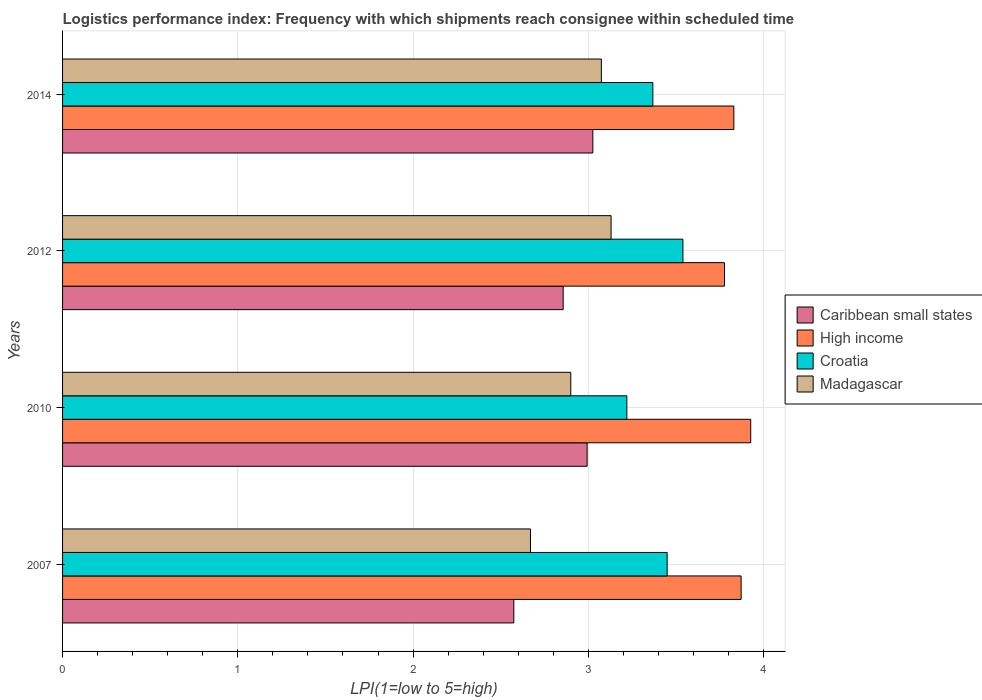How many different coloured bars are there?
Give a very brief answer. 4. Are the number of bars per tick equal to the number of legend labels?
Offer a terse response. Yes. How many bars are there on the 2nd tick from the top?
Offer a very short reply. 4. How many bars are there on the 1st tick from the bottom?
Your response must be concise. 4. What is the logistics performance index in Caribbean small states in 2012?
Ensure brevity in your answer.  2.86. Across all years, what is the maximum logistics performance index in High income?
Offer a very short reply. 3.93. Across all years, what is the minimum logistics performance index in High income?
Your response must be concise. 3.78. In which year was the logistics performance index in Madagascar maximum?
Keep it short and to the point. 2012. What is the total logistics performance index in Madagascar in the graph?
Give a very brief answer. 11.77. What is the difference between the logistics performance index in Madagascar in 2010 and that in 2012?
Give a very brief answer. -0.23. What is the difference between the logistics performance index in Caribbean small states in 2014 and the logistics performance index in Madagascar in 2012?
Provide a short and direct response. -0.1. What is the average logistics performance index in High income per year?
Your answer should be compact. 3.85. In the year 2014, what is the difference between the logistics performance index in Madagascar and logistics performance index in Croatia?
Keep it short and to the point. -0.29. What is the ratio of the logistics performance index in High income in 2007 to that in 2012?
Your response must be concise. 1.03. Is the difference between the logistics performance index in Madagascar in 2010 and 2014 greater than the difference between the logistics performance index in Croatia in 2010 and 2014?
Give a very brief answer. No. What is the difference between the highest and the second highest logistics performance index in Croatia?
Provide a succinct answer. 0.09. What is the difference between the highest and the lowest logistics performance index in Caribbean small states?
Give a very brief answer. 0.45. In how many years, is the logistics performance index in Caribbean small states greater than the average logistics performance index in Caribbean small states taken over all years?
Ensure brevity in your answer.  2. Is the sum of the logistics performance index in Madagascar in 2007 and 2012 greater than the maximum logistics performance index in Croatia across all years?
Offer a terse response. Yes. Is it the case that in every year, the sum of the logistics performance index in Madagascar and logistics performance index in Croatia is greater than the sum of logistics performance index in Caribbean small states and logistics performance index in High income?
Keep it short and to the point. No. How many bars are there?
Your answer should be very brief. 16. How many years are there in the graph?
Give a very brief answer. 4. Are the values on the major ticks of X-axis written in scientific E-notation?
Offer a very short reply. No. How many legend labels are there?
Offer a terse response. 4. What is the title of the graph?
Your answer should be very brief. Logistics performance index: Frequency with which shipments reach consignee within scheduled time. What is the label or title of the X-axis?
Make the answer very short. LPI(1=low to 5=high). What is the label or title of the Y-axis?
Keep it short and to the point. Years. What is the LPI(1=low to 5=high) of Caribbean small states in 2007?
Ensure brevity in your answer.  2.58. What is the LPI(1=low to 5=high) of High income in 2007?
Ensure brevity in your answer.  3.87. What is the LPI(1=low to 5=high) in Croatia in 2007?
Give a very brief answer. 3.45. What is the LPI(1=low to 5=high) of Madagascar in 2007?
Make the answer very short. 2.67. What is the LPI(1=low to 5=high) in Caribbean small states in 2010?
Keep it short and to the point. 2.99. What is the LPI(1=low to 5=high) in High income in 2010?
Give a very brief answer. 3.93. What is the LPI(1=low to 5=high) of Croatia in 2010?
Your answer should be compact. 3.22. What is the LPI(1=low to 5=high) of Madagascar in 2010?
Ensure brevity in your answer.  2.9. What is the LPI(1=low to 5=high) of Caribbean small states in 2012?
Give a very brief answer. 2.86. What is the LPI(1=low to 5=high) in High income in 2012?
Give a very brief answer. 3.78. What is the LPI(1=low to 5=high) in Croatia in 2012?
Your response must be concise. 3.54. What is the LPI(1=low to 5=high) of Madagascar in 2012?
Ensure brevity in your answer.  3.13. What is the LPI(1=low to 5=high) in Caribbean small states in 2014?
Keep it short and to the point. 3.03. What is the LPI(1=low to 5=high) in High income in 2014?
Ensure brevity in your answer.  3.83. What is the LPI(1=low to 5=high) of Croatia in 2014?
Your answer should be compact. 3.37. What is the LPI(1=low to 5=high) of Madagascar in 2014?
Your response must be concise. 3.07. Across all years, what is the maximum LPI(1=low to 5=high) in Caribbean small states?
Offer a very short reply. 3.03. Across all years, what is the maximum LPI(1=low to 5=high) of High income?
Ensure brevity in your answer.  3.93. Across all years, what is the maximum LPI(1=low to 5=high) in Croatia?
Keep it short and to the point. 3.54. Across all years, what is the maximum LPI(1=low to 5=high) of Madagascar?
Ensure brevity in your answer.  3.13. Across all years, what is the minimum LPI(1=low to 5=high) of Caribbean small states?
Make the answer very short. 2.58. Across all years, what is the minimum LPI(1=low to 5=high) of High income?
Keep it short and to the point. 3.78. Across all years, what is the minimum LPI(1=low to 5=high) in Croatia?
Your answer should be very brief. 3.22. Across all years, what is the minimum LPI(1=low to 5=high) of Madagascar?
Provide a succinct answer. 2.67. What is the total LPI(1=low to 5=high) in Caribbean small states in the graph?
Ensure brevity in your answer.  11.45. What is the total LPI(1=low to 5=high) of High income in the graph?
Your answer should be compact. 15.41. What is the total LPI(1=low to 5=high) of Croatia in the graph?
Make the answer very short. 13.58. What is the total LPI(1=low to 5=high) in Madagascar in the graph?
Ensure brevity in your answer.  11.77. What is the difference between the LPI(1=low to 5=high) in Caribbean small states in 2007 and that in 2010?
Your response must be concise. -0.42. What is the difference between the LPI(1=low to 5=high) in High income in 2007 and that in 2010?
Keep it short and to the point. -0.05. What is the difference between the LPI(1=low to 5=high) in Croatia in 2007 and that in 2010?
Your answer should be very brief. 0.23. What is the difference between the LPI(1=low to 5=high) in Madagascar in 2007 and that in 2010?
Your answer should be compact. -0.23. What is the difference between the LPI(1=low to 5=high) of Caribbean small states in 2007 and that in 2012?
Offer a very short reply. -0.28. What is the difference between the LPI(1=low to 5=high) in High income in 2007 and that in 2012?
Keep it short and to the point. 0.09. What is the difference between the LPI(1=low to 5=high) of Croatia in 2007 and that in 2012?
Provide a short and direct response. -0.09. What is the difference between the LPI(1=low to 5=high) of Madagascar in 2007 and that in 2012?
Your answer should be compact. -0.46. What is the difference between the LPI(1=low to 5=high) of Caribbean small states in 2007 and that in 2014?
Offer a very short reply. -0.45. What is the difference between the LPI(1=low to 5=high) of High income in 2007 and that in 2014?
Your answer should be very brief. 0.04. What is the difference between the LPI(1=low to 5=high) of Croatia in 2007 and that in 2014?
Offer a terse response. 0.08. What is the difference between the LPI(1=low to 5=high) of Madagascar in 2007 and that in 2014?
Provide a succinct answer. -0.4. What is the difference between the LPI(1=low to 5=high) in Caribbean small states in 2010 and that in 2012?
Give a very brief answer. 0.14. What is the difference between the LPI(1=low to 5=high) in High income in 2010 and that in 2012?
Offer a very short reply. 0.15. What is the difference between the LPI(1=low to 5=high) of Croatia in 2010 and that in 2012?
Offer a very short reply. -0.32. What is the difference between the LPI(1=low to 5=high) of Madagascar in 2010 and that in 2012?
Make the answer very short. -0.23. What is the difference between the LPI(1=low to 5=high) in Caribbean small states in 2010 and that in 2014?
Make the answer very short. -0.03. What is the difference between the LPI(1=low to 5=high) in High income in 2010 and that in 2014?
Ensure brevity in your answer.  0.1. What is the difference between the LPI(1=low to 5=high) in Croatia in 2010 and that in 2014?
Provide a short and direct response. -0.15. What is the difference between the LPI(1=low to 5=high) in Madagascar in 2010 and that in 2014?
Your answer should be compact. -0.17. What is the difference between the LPI(1=low to 5=high) of Caribbean small states in 2012 and that in 2014?
Keep it short and to the point. -0.17. What is the difference between the LPI(1=low to 5=high) of High income in 2012 and that in 2014?
Your response must be concise. -0.05. What is the difference between the LPI(1=low to 5=high) of Croatia in 2012 and that in 2014?
Keep it short and to the point. 0.17. What is the difference between the LPI(1=low to 5=high) of Madagascar in 2012 and that in 2014?
Provide a short and direct response. 0.06. What is the difference between the LPI(1=low to 5=high) of Caribbean small states in 2007 and the LPI(1=low to 5=high) of High income in 2010?
Give a very brief answer. -1.35. What is the difference between the LPI(1=low to 5=high) in Caribbean small states in 2007 and the LPI(1=low to 5=high) in Croatia in 2010?
Give a very brief answer. -0.65. What is the difference between the LPI(1=low to 5=high) in Caribbean small states in 2007 and the LPI(1=low to 5=high) in Madagascar in 2010?
Give a very brief answer. -0.33. What is the difference between the LPI(1=low to 5=high) in High income in 2007 and the LPI(1=low to 5=high) in Croatia in 2010?
Provide a short and direct response. 0.65. What is the difference between the LPI(1=low to 5=high) in High income in 2007 and the LPI(1=low to 5=high) in Madagascar in 2010?
Offer a very short reply. 0.97. What is the difference between the LPI(1=low to 5=high) of Croatia in 2007 and the LPI(1=low to 5=high) of Madagascar in 2010?
Offer a very short reply. 0.55. What is the difference between the LPI(1=low to 5=high) of Caribbean small states in 2007 and the LPI(1=low to 5=high) of High income in 2012?
Make the answer very short. -1.2. What is the difference between the LPI(1=low to 5=high) of Caribbean small states in 2007 and the LPI(1=low to 5=high) of Croatia in 2012?
Keep it short and to the point. -0.96. What is the difference between the LPI(1=low to 5=high) in Caribbean small states in 2007 and the LPI(1=low to 5=high) in Madagascar in 2012?
Your response must be concise. -0.56. What is the difference between the LPI(1=low to 5=high) of High income in 2007 and the LPI(1=low to 5=high) of Croatia in 2012?
Offer a terse response. 0.33. What is the difference between the LPI(1=low to 5=high) of High income in 2007 and the LPI(1=low to 5=high) of Madagascar in 2012?
Provide a short and direct response. 0.74. What is the difference between the LPI(1=low to 5=high) of Croatia in 2007 and the LPI(1=low to 5=high) of Madagascar in 2012?
Give a very brief answer. 0.32. What is the difference between the LPI(1=low to 5=high) of Caribbean small states in 2007 and the LPI(1=low to 5=high) of High income in 2014?
Give a very brief answer. -1.26. What is the difference between the LPI(1=low to 5=high) in Caribbean small states in 2007 and the LPI(1=low to 5=high) in Croatia in 2014?
Your response must be concise. -0.79. What is the difference between the LPI(1=low to 5=high) in Caribbean small states in 2007 and the LPI(1=low to 5=high) in Madagascar in 2014?
Your answer should be compact. -0.5. What is the difference between the LPI(1=low to 5=high) in High income in 2007 and the LPI(1=low to 5=high) in Croatia in 2014?
Your answer should be very brief. 0.5. What is the difference between the LPI(1=low to 5=high) in High income in 2007 and the LPI(1=low to 5=high) in Madagascar in 2014?
Provide a succinct answer. 0.8. What is the difference between the LPI(1=low to 5=high) in Croatia in 2007 and the LPI(1=low to 5=high) in Madagascar in 2014?
Your response must be concise. 0.38. What is the difference between the LPI(1=low to 5=high) of Caribbean small states in 2010 and the LPI(1=low to 5=high) of High income in 2012?
Provide a succinct answer. -0.78. What is the difference between the LPI(1=low to 5=high) of Caribbean small states in 2010 and the LPI(1=low to 5=high) of Croatia in 2012?
Your answer should be compact. -0.55. What is the difference between the LPI(1=low to 5=high) of Caribbean small states in 2010 and the LPI(1=low to 5=high) of Madagascar in 2012?
Offer a very short reply. -0.14. What is the difference between the LPI(1=low to 5=high) in High income in 2010 and the LPI(1=low to 5=high) in Croatia in 2012?
Make the answer very short. 0.39. What is the difference between the LPI(1=low to 5=high) of High income in 2010 and the LPI(1=low to 5=high) of Madagascar in 2012?
Offer a very short reply. 0.8. What is the difference between the LPI(1=low to 5=high) in Croatia in 2010 and the LPI(1=low to 5=high) in Madagascar in 2012?
Your answer should be compact. 0.09. What is the difference between the LPI(1=low to 5=high) in Caribbean small states in 2010 and the LPI(1=low to 5=high) in High income in 2014?
Your answer should be compact. -0.84. What is the difference between the LPI(1=low to 5=high) in Caribbean small states in 2010 and the LPI(1=low to 5=high) in Croatia in 2014?
Your response must be concise. -0.38. What is the difference between the LPI(1=low to 5=high) in Caribbean small states in 2010 and the LPI(1=low to 5=high) in Madagascar in 2014?
Offer a terse response. -0.08. What is the difference between the LPI(1=low to 5=high) in High income in 2010 and the LPI(1=low to 5=high) in Croatia in 2014?
Provide a succinct answer. 0.56. What is the difference between the LPI(1=low to 5=high) in High income in 2010 and the LPI(1=low to 5=high) in Madagascar in 2014?
Make the answer very short. 0.85. What is the difference between the LPI(1=low to 5=high) in Croatia in 2010 and the LPI(1=low to 5=high) in Madagascar in 2014?
Keep it short and to the point. 0.15. What is the difference between the LPI(1=low to 5=high) of Caribbean small states in 2012 and the LPI(1=low to 5=high) of High income in 2014?
Give a very brief answer. -0.97. What is the difference between the LPI(1=low to 5=high) in Caribbean small states in 2012 and the LPI(1=low to 5=high) in Croatia in 2014?
Give a very brief answer. -0.51. What is the difference between the LPI(1=low to 5=high) of Caribbean small states in 2012 and the LPI(1=low to 5=high) of Madagascar in 2014?
Your response must be concise. -0.22. What is the difference between the LPI(1=low to 5=high) of High income in 2012 and the LPI(1=low to 5=high) of Croatia in 2014?
Your response must be concise. 0.41. What is the difference between the LPI(1=low to 5=high) in High income in 2012 and the LPI(1=low to 5=high) in Madagascar in 2014?
Offer a very short reply. 0.7. What is the difference between the LPI(1=low to 5=high) of Croatia in 2012 and the LPI(1=low to 5=high) of Madagascar in 2014?
Your answer should be very brief. 0.47. What is the average LPI(1=low to 5=high) in Caribbean small states per year?
Make the answer very short. 2.86. What is the average LPI(1=low to 5=high) of High income per year?
Keep it short and to the point. 3.85. What is the average LPI(1=low to 5=high) of Croatia per year?
Offer a terse response. 3.39. What is the average LPI(1=low to 5=high) of Madagascar per year?
Provide a short and direct response. 2.94. In the year 2007, what is the difference between the LPI(1=low to 5=high) in Caribbean small states and LPI(1=low to 5=high) in High income?
Your response must be concise. -1.3. In the year 2007, what is the difference between the LPI(1=low to 5=high) of Caribbean small states and LPI(1=low to 5=high) of Croatia?
Your answer should be very brief. -0.88. In the year 2007, what is the difference between the LPI(1=low to 5=high) of Caribbean small states and LPI(1=low to 5=high) of Madagascar?
Your answer should be very brief. -0.1. In the year 2007, what is the difference between the LPI(1=low to 5=high) of High income and LPI(1=low to 5=high) of Croatia?
Make the answer very short. 0.42. In the year 2007, what is the difference between the LPI(1=low to 5=high) in High income and LPI(1=low to 5=high) in Madagascar?
Make the answer very short. 1.2. In the year 2007, what is the difference between the LPI(1=low to 5=high) in Croatia and LPI(1=low to 5=high) in Madagascar?
Offer a terse response. 0.78. In the year 2010, what is the difference between the LPI(1=low to 5=high) in Caribbean small states and LPI(1=low to 5=high) in High income?
Provide a succinct answer. -0.93. In the year 2010, what is the difference between the LPI(1=low to 5=high) in Caribbean small states and LPI(1=low to 5=high) in Croatia?
Your response must be concise. -0.23. In the year 2010, what is the difference between the LPI(1=low to 5=high) in Caribbean small states and LPI(1=low to 5=high) in Madagascar?
Your response must be concise. 0.09. In the year 2010, what is the difference between the LPI(1=low to 5=high) in High income and LPI(1=low to 5=high) in Croatia?
Your answer should be compact. 0.71. In the year 2010, what is the difference between the LPI(1=low to 5=high) of High income and LPI(1=low to 5=high) of Madagascar?
Your answer should be very brief. 1.03. In the year 2010, what is the difference between the LPI(1=low to 5=high) of Croatia and LPI(1=low to 5=high) of Madagascar?
Your answer should be very brief. 0.32. In the year 2012, what is the difference between the LPI(1=low to 5=high) in Caribbean small states and LPI(1=low to 5=high) in High income?
Your response must be concise. -0.92. In the year 2012, what is the difference between the LPI(1=low to 5=high) in Caribbean small states and LPI(1=low to 5=high) in Croatia?
Your response must be concise. -0.68. In the year 2012, what is the difference between the LPI(1=low to 5=high) in Caribbean small states and LPI(1=low to 5=high) in Madagascar?
Your response must be concise. -0.27. In the year 2012, what is the difference between the LPI(1=low to 5=high) in High income and LPI(1=low to 5=high) in Croatia?
Offer a terse response. 0.24. In the year 2012, what is the difference between the LPI(1=low to 5=high) of High income and LPI(1=low to 5=high) of Madagascar?
Provide a short and direct response. 0.65. In the year 2012, what is the difference between the LPI(1=low to 5=high) of Croatia and LPI(1=low to 5=high) of Madagascar?
Your response must be concise. 0.41. In the year 2014, what is the difference between the LPI(1=low to 5=high) of Caribbean small states and LPI(1=low to 5=high) of High income?
Keep it short and to the point. -0.8. In the year 2014, what is the difference between the LPI(1=low to 5=high) in Caribbean small states and LPI(1=low to 5=high) in Croatia?
Make the answer very short. -0.34. In the year 2014, what is the difference between the LPI(1=low to 5=high) of Caribbean small states and LPI(1=low to 5=high) of Madagascar?
Make the answer very short. -0.05. In the year 2014, what is the difference between the LPI(1=low to 5=high) of High income and LPI(1=low to 5=high) of Croatia?
Your answer should be compact. 0.46. In the year 2014, what is the difference between the LPI(1=low to 5=high) of High income and LPI(1=low to 5=high) of Madagascar?
Your answer should be compact. 0.76. In the year 2014, what is the difference between the LPI(1=low to 5=high) of Croatia and LPI(1=low to 5=high) of Madagascar?
Make the answer very short. 0.29. What is the ratio of the LPI(1=low to 5=high) in Caribbean small states in 2007 to that in 2010?
Your answer should be very brief. 0.86. What is the ratio of the LPI(1=low to 5=high) of High income in 2007 to that in 2010?
Your answer should be very brief. 0.99. What is the ratio of the LPI(1=low to 5=high) in Croatia in 2007 to that in 2010?
Give a very brief answer. 1.07. What is the ratio of the LPI(1=low to 5=high) in Madagascar in 2007 to that in 2010?
Your answer should be compact. 0.92. What is the ratio of the LPI(1=low to 5=high) of Caribbean small states in 2007 to that in 2012?
Ensure brevity in your answer.  0.9. What is the ratio of the LPI(1=low to 5=high) of High income in 2007 to that in 2012?
Your answer should be very brief. 1.03. What is the ratio of the LPI(1=low to 5=high) in Croatia in 2007 to that in 2012?
Offer a very short reply. 0.97. What is the ratio of the LPI(1=low to 5=high) in Madagascar in 2007 to that in 2012?
Your answer should be very brief. 0.85. What is the ratio of the LPI(1=low to 5=high) of Caribbean small states in 2007 to that in 2014?
Provide a succinct answer. 0.85. What is the ratio of the LPI(1=low to 5=high) in High income in 2007 to that in 2014?
Your response must be concise. 1.01. What is the ratio of the LPI(1=low to 5=high) in Croatia in 2007 to that in 2014?
Provide a succinct answer. 1.02. What is the ratio of the LPI(1=low to 5=high) in Madagascar in 2007 to that in 2014?
Make the answer very short. 0.87. What is the ratio of the LPI(1=low to 5=high) in Caribbean small states in 2010 to that in 2012?
Your response must be concise. 1.05. What is the ratio of the LPI(1=low to 5=high) of High income in 2010 to that in 2012?
Make the answer very short. 1.04. What is the ratio of the LPI(1=low to 5=high) in Croatia in 2010 to that in 2012?
Offer a terse response. 0.91. What is the ratio of the LPI(1=low to 5=high) of Madagascar in 2010 to that in 2012?
Keep it short and to the point. 0.93. What is the ratio of the LPI(1=low to 5=high) in Caribbean small states in 2010 to that in 2014?
Provide a short and direct response. 0.99. What is the ratio of the LPI(1=low to 5=high) of High income in 2010 to that in 2014?
Your response must be concise. 1.03. What is the ratio of the LPI(1=low to 5=high) of Croatia in 2010 to that in 2014?
Your response must be concise. 0.96. What is the ratio of the LPI(1=low to 5=high) in Madagascar in 2010 to that in 2014?
Your answer should be very brief. 0.94. What is the ratio of the LPI(1=low to 5=high) in Caribbean small states in 2012 to that in 2014?
Your answer should be very brief. 0.94. What is the ratio of the LPI(1=low to 5=high) of High income in 2012 to that in 2014?
Keep it short and to the point. 0.99. What is the ratio of the LPI(1=low to 5=high) in Croatia in 2012 to that in 2014?
Your answer should be very brief. 1.05. What is the ratio of the LPI(1=low to 5=high) in Madagascar in 2012 to that in 2014?
Offer a very short reply. 1.02. What is the difference between the highest and the second highest LPI(1=low to 5=high) of Caribbean small states?
Make the answer very short. 0.03. What is the difference between the highest and the second highest LPI(1=low to 5=high) in High income?
Offer a very short reply. 0.05. What is the difference between the highest and the second highest LPI(1=low to 5=high) of Croatia?
Your answer should be compact. 0.09. What is the difference between the highest and the second highest LPI(1=low to 5=high) in Madagascar?
Your response must be concise. 0.06. What is the difference between the highest and the lowest LPI(1=low to 5=high) in Caribbean small states?
Your answer should be very brief. 0.45. What is the difference between the highest and the lowest LPI(1=low to 5=high) of High income?
Make the answer very short. 0.15. What is the difference between the highest and the lowest LPI(1=low to 5=high) in Croatia?
Make the answer very short. 0.32. What is the difference between the highest and the lowest LPI(1=low to 5=high) in Madagascar?
Your response must be concise. 0.46. 